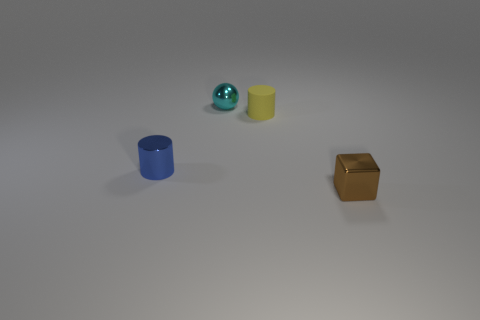Is there anything else that is the same material as the small yellow object?
Provide a succinct answer. No. Are there any other things of the same color as the tiny metal sphere?
Provide a short and direct response. No. There is a small metal object that is in front of the blue metallic object in front of the small cyan ball; what is its color?
Give a very brief answer. Brown. Is the number of cyan things that are on the right side of the metallic sphere less than the number of tiny cylinders behind the small yellow cylinder?
Offer a very short reply. No. What number of things are objects that are behind the small brown metal thing or small metal cylinders?
Your answer should be compact. 3. Does the cylinder on the left side of the cyan metallic object have the same size as the rubber thing?
Your response must be concise. Yes. Are there fewer cyan metallic objects behind the small blue shiny object than objects?
Give a very brief answer. Yes. There is a cube that is the same size as the blue cylinder; what is it made of?
Keep it short and to the point. Metal. How many tiny things are either shiny blocks or spheres?
Offer a terse response. 2. How many objects are either tiny things that are behind the brown object or objects that are behind the brown metallic thing?
Your response must be concise. 3. 